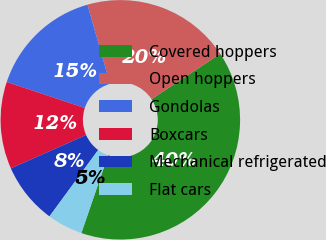Convert chart. <chart><loc_0><loc_0><loc_500><loc_500><pie_chart><fcel>Covered hoppers<fcel>Open hoppers<fcel>Gondolas<fcel>Boxcars<fcel>Mechanical refrigerated<fcel>Flat cars<nl><fcel>39.58%<fcel>20.13%<fcel>15.46%<fcel>11.76%<fcel>8.28%<fcel>4.8%<nl></chart> 